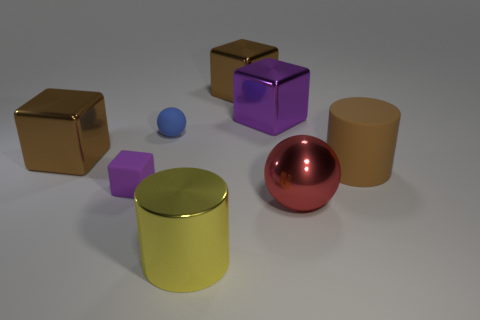Is the number of things that are behind the blue rubber sphere the same as the number of big brown objects behind the large rubber object?
Make the answer very short. Yes. What is the material of the other big thing that is the same shape as the yellow object?
Offer a terse response. Rubber. There is a brown metallic thing behind the large brown block on the left side of the tiny blue sphere; are there any big blocks that are in front of it?
Make the answer very short. Yes. Do the purple thing in front of the tiny blue matte ball and the brown metallic thing behind the purple metallic thing have the same shape?
Make the answer very short. Yes. Are there more purple things that are right of the matte ball than tiny green balls?
Offer a terse response. Yes. What number of things are either large brown metallic blocks or big rubber blocks?
Your answer should be very brief. 2. What color is the big sphere?
Give a very brief answer. Red. What number of other objects are the same color as the rubber sphere?
Offer a terse response. 0. Are there any brown objects behind the metallic cylinder?
Offer a terse response. Yes. What is the color of the big cylinder that is in front of the sphere that is in front of the large cylinder behind the large red sphere?
Ensure brevity in your answer.  Yellow. 